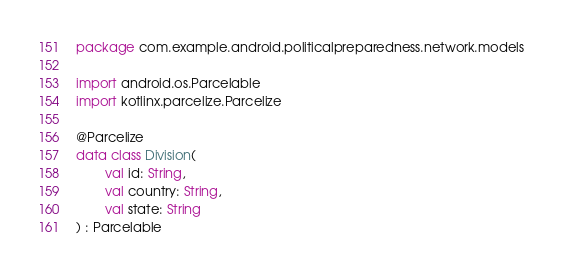<code> <loc_0><loc_0><loc_500><loc_500><_Kotlin_>package com.example.android.politicalpreparedness.network.models

import android.os.Parcelable
import kotlinx.parcelize.Parcelize

@Parcelize
data class Division(
        val id: String,
        val country: String,
        val state: String
) : Parcelable</code> 